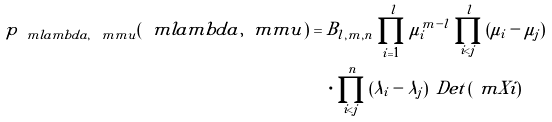Convert formula to latex. <formula><loc_0><loc_0><loc_500><loc_500>p _ { \ m l a m b d a , \ m m u } ( \ m l a m b d a , \ m m u ) & = B _ { l , m , n } \prod _ { i = 1 } ^ { l } \mu _ { i } ^ { m - l } \prod _ { i < j } ^ { l } { ( \mu _ { i } - \mu _ { j } ) } \\ & \quad \cdot \prod _ { i < j } ^ { n } { ( \lambda _ { i } - \lambda _ { j } ) } \, \ D e t \left ( \ m X i \right )</formula> 